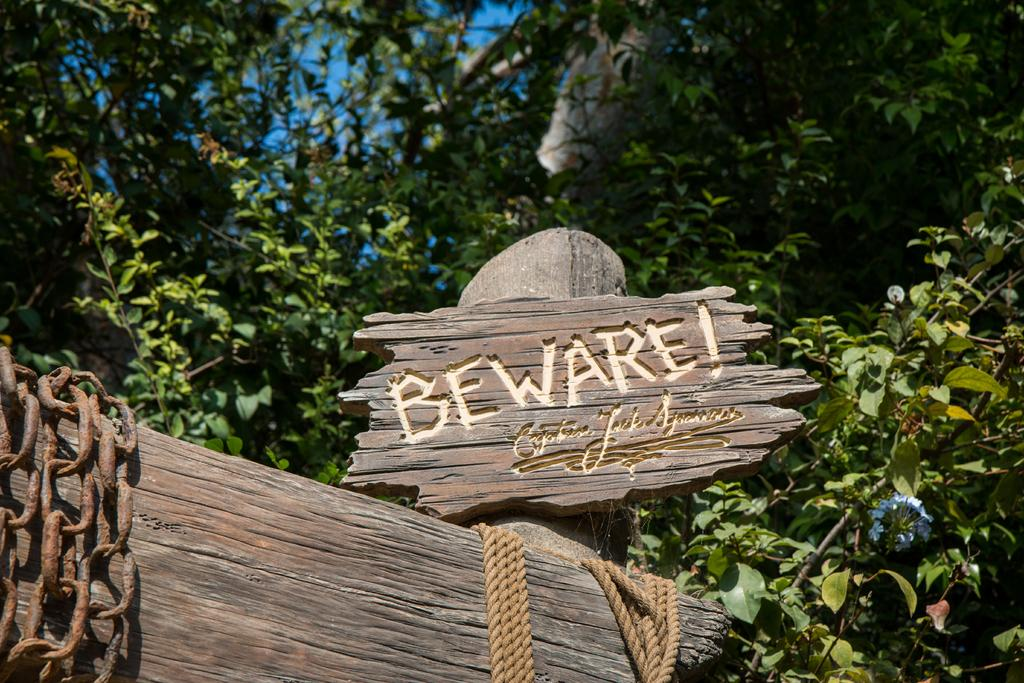What material is the main object in the image made of? The main object in the image is a wooden board. What is written or carved on the wooden board? Text is carved on the wooden board. What type of objects are present that are typically used for tying or securing? There are ropes and a chain in the image. What other wooden object can be seen in the image? There is a wooden stick in the image. What can be seen in the background of the image? There are trees and the sky visible in the background of the image. Can you tell me how many mint leaves are floating in the water in the image? There are no mint leaves or water present in the image; it features a wooden board with text, ropes, a chain, and a wooden stick. 